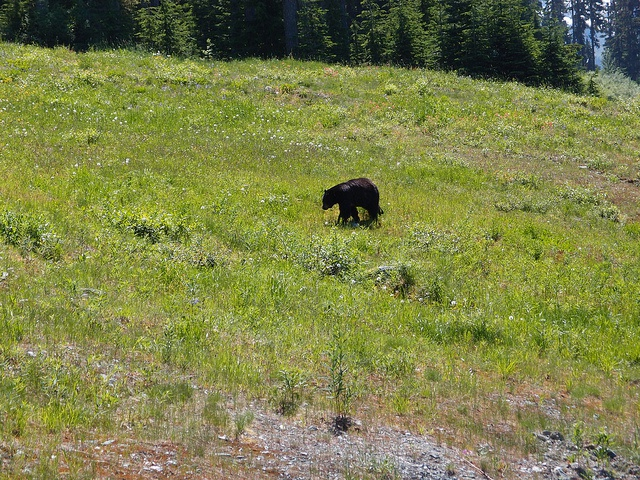Describe the objects in this image and their specific colors. I can see a bear in black, gray, and olive tones in this image. 